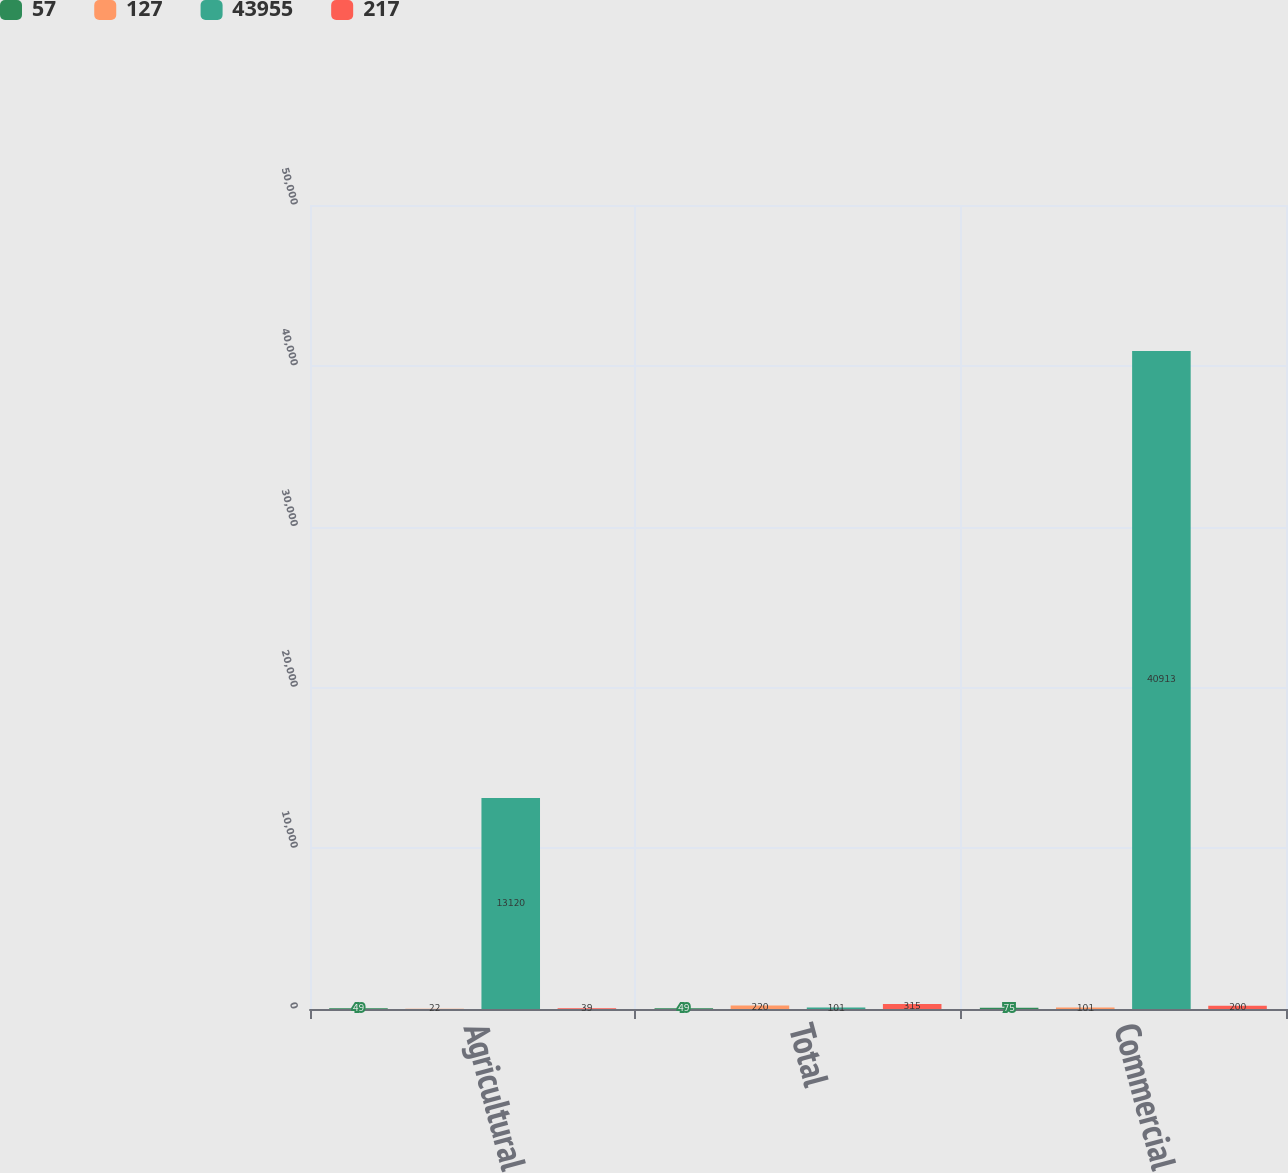<chart> <loc_0><loc_0><loc_500><loc_500><stacked_bar_chart><ecel><fcel>Agricultural<fcel>Total<fcel>Commercial<nl><fcel>57<fcel>49<fcel>49<fcel>75<nl><fcel>127<fcel>22<fcel>220<fcel>101<nl><fcel>43955<fcel>13120<fcel>101<fcel>40913<nl><fcel>217<fcel>39<fcel>315<fcel>200<nl></chart> 